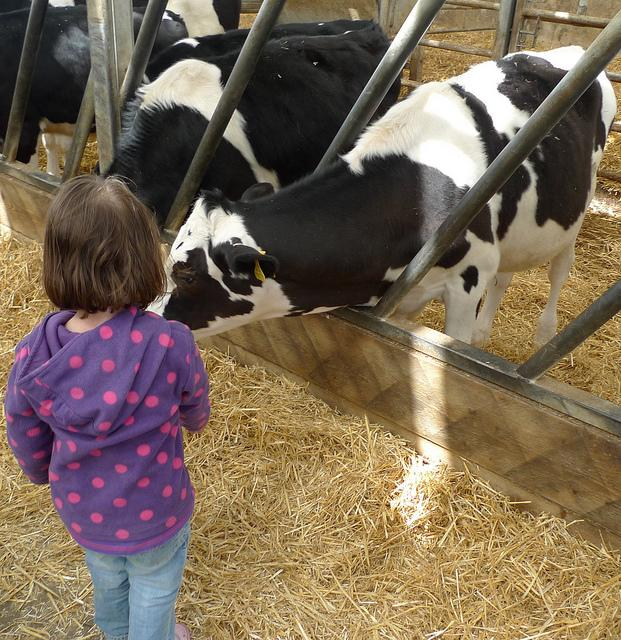What design is on the little girl's hoodie?

Choices:
A) stripes
B) polka dots
C) medusa heads
D) stars polka dots 